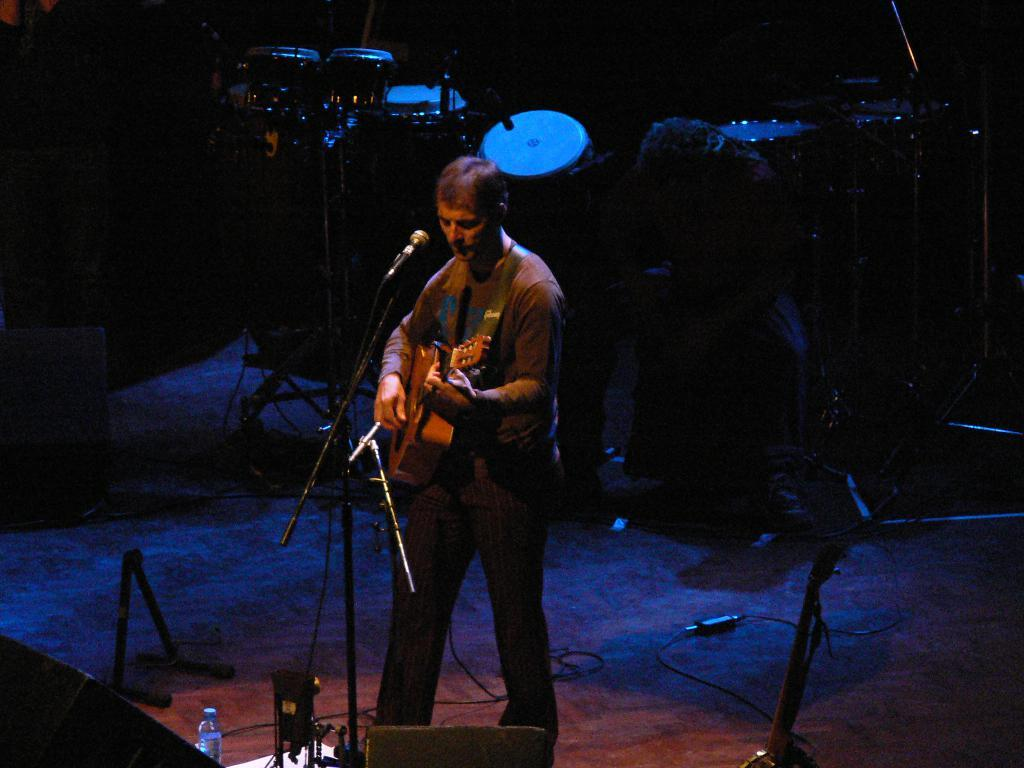Who is the main subject in the image? There is a man in the image. What is the man doing in the image? The man is standing and playing a guitar. What is the man using to amplify his voice in the image? There is a microphone in front of the man. What other musical instrument can be seen in the image? There are drums visible in the image. What type of carriage is being pulled by the horses in the image? There are no horses or carriages present in the image; it features a man playing a guitar and drums. What is the skin condition of the man in the image? There is no information about the man's skin condition in the image. 